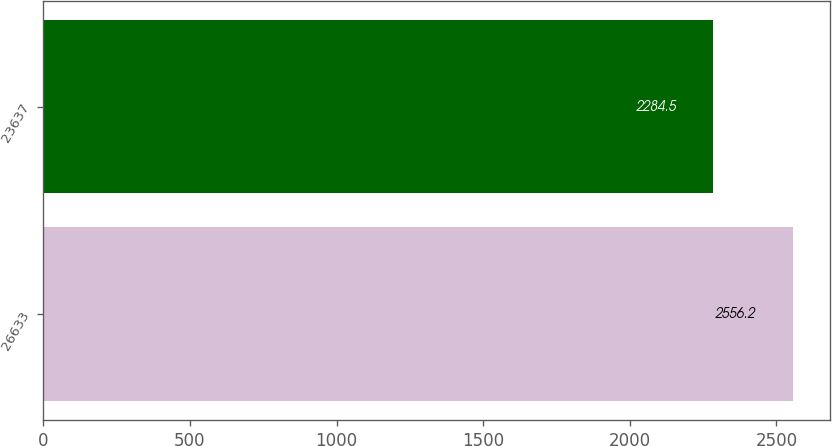Convert chart to OTSL. <chart><loc_0><loc_0><loc_500><loc_500><bar_chart><fcel>26633<fcel>23637<nl><fcel>2556.2<fcel>2284.5<nl></chart> 